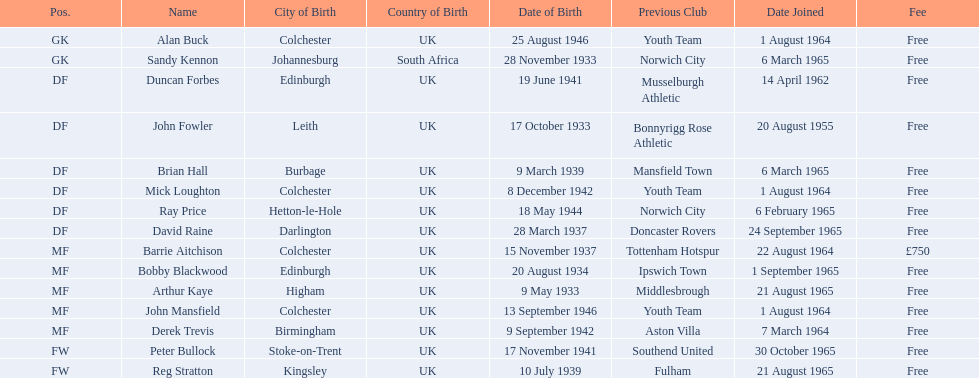When did alan buck join the colchester united f.c. in 1965-66? 1 August 1964. When did the last player to join? Peter Bullock. What date did the first player join? 20 August 1955. 